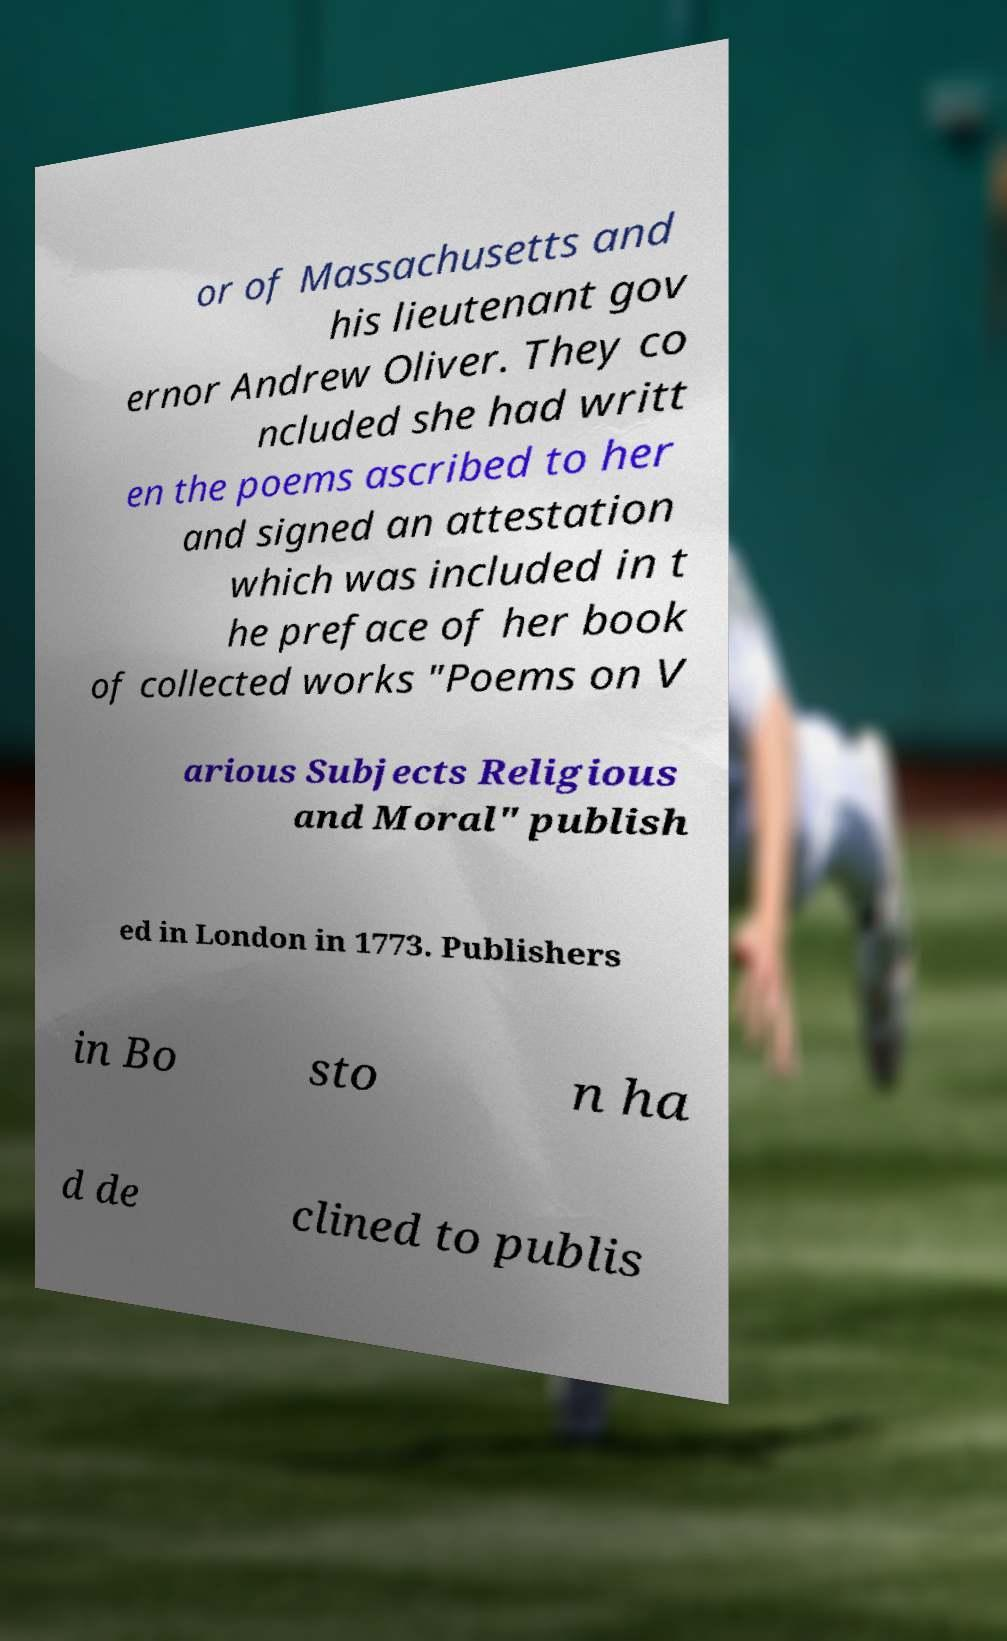For documentation purposes, I need the text within this image transcribed. Could you provide that? or of Massachusetts and his lieutenant gov ernor Andrew Oliver. They co ncluded she had writt en the poems ascribed to her and signed an attestation which was included in t he preface of her book of collected works "Poems on V arious Subjects Religious and Moral" publish ed in London in 1773. Publishers in Bo sto n ha d de clined to publis 